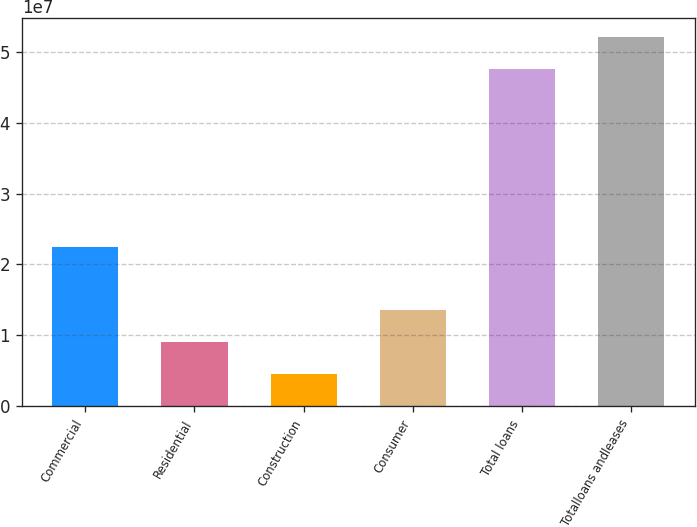Convert chart. <chart><loc_0><loc_0><loc_500><loc_500><bar_chart><fcel>Commercial<fcel>Residential<fcel>Construction<fcel>Consumer<fcel>Total loans<fcel>Totalloans andleases<nl><fcel>2.24849e+07<fcel>9.0475e+06<fcel>4.56837e+06<fcel>1.35266e+07<fcel>4.76447e+07<fcel>5.21239e+07<nl></chart> 